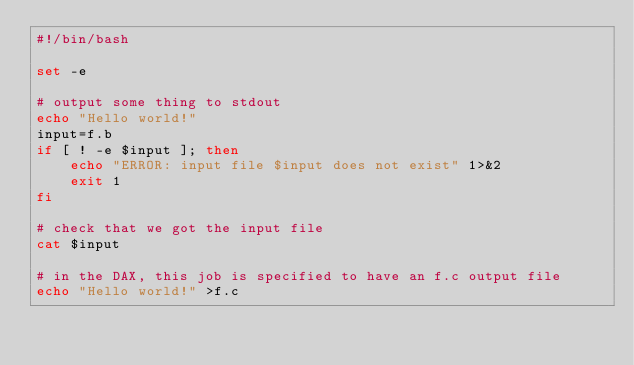Convert code to text. <code><loc_0><loc_0><loc_500><loc_500><_Bash_>#!/bin/bash

set -e

# output some thing to stdout
echo "Hello world!"
input=f.b
if [ ! -e $input ]; then
    echo "ERROR: input file $input does not exist" 1>&2
    exit 1
fi

# check that we got the input file
cat $input

# in the DAX, this job is specified to have an f.c output file
echo "Hello world!" >f.c

</code> 